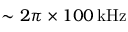<formula> <loc_0><loc_0><loc_500><loc_500>\sim 2 \pi \times 1 0 0 \, k H z</formula> 